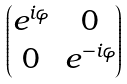<formula> <loc_0><loc_0><loc_500><loc_500>\begin{pmatrix} e ^ { i \varphi } & 0 \\ 0 & e ^ { - i \varphi } \end{pmatrix}</formula> 